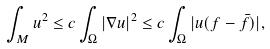<formula> <loc_0><loc_0><loc_500><loc_500>\int _ { M } u ^ { 2 } \leq c \int _ { \Omega } | \nabla u | ^ { 2 } \leq c \int _ { \Omega } | u ( f - \bar { f } ) | ,</formula> 